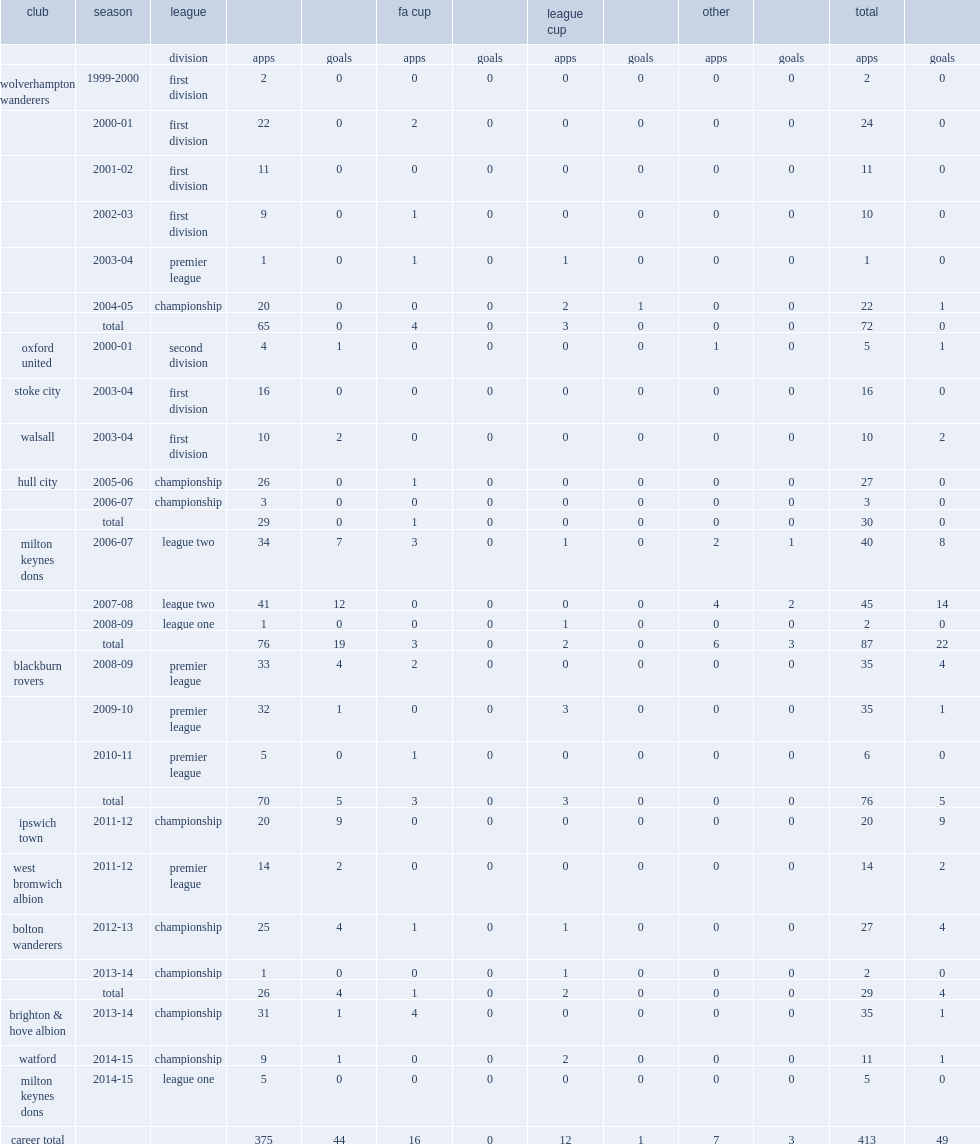Which league did keith andrews move to milton keynes dons for the 2006-07 campaign? League two. 